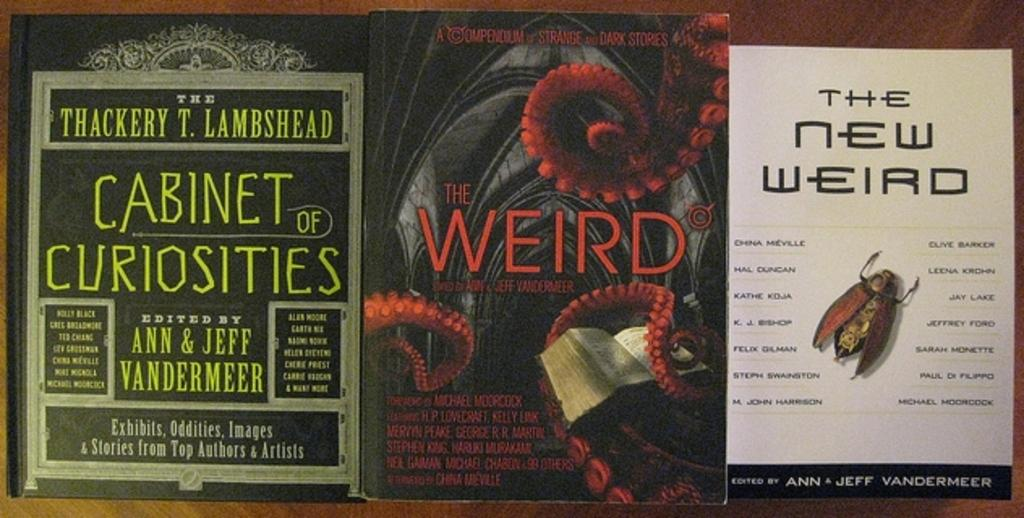<image>
Relay a brief, clear account of the picture shown. One of the books  is titled The New Weird 